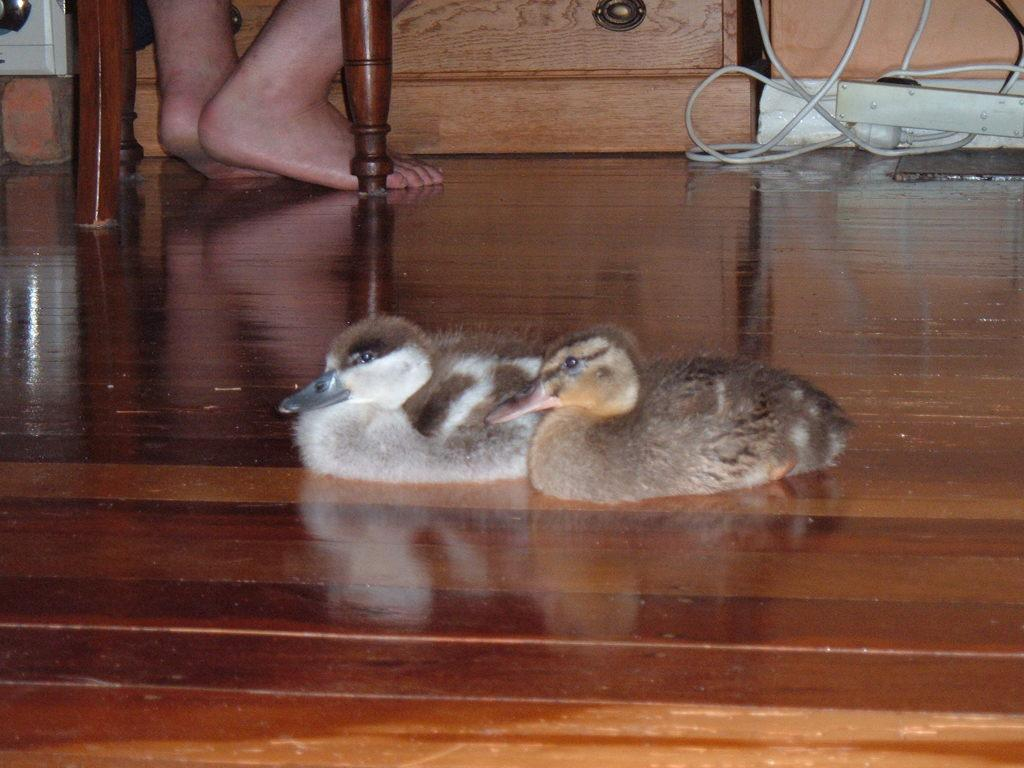How many chickens are in the image? There are two chickens in the image. What type of surface are the chickens sitting on? The chickens are sitting on a wooden floor. Can you describe the legs of the wooden floor? The legs of the wooden floor are visible behind the chickens. What is present on the right side of the image? There is a wire in front of a cupboard on the right side of the image. What type of cherries are hanging from the guitar in the image? There is no guitar or cherries present in the image. 